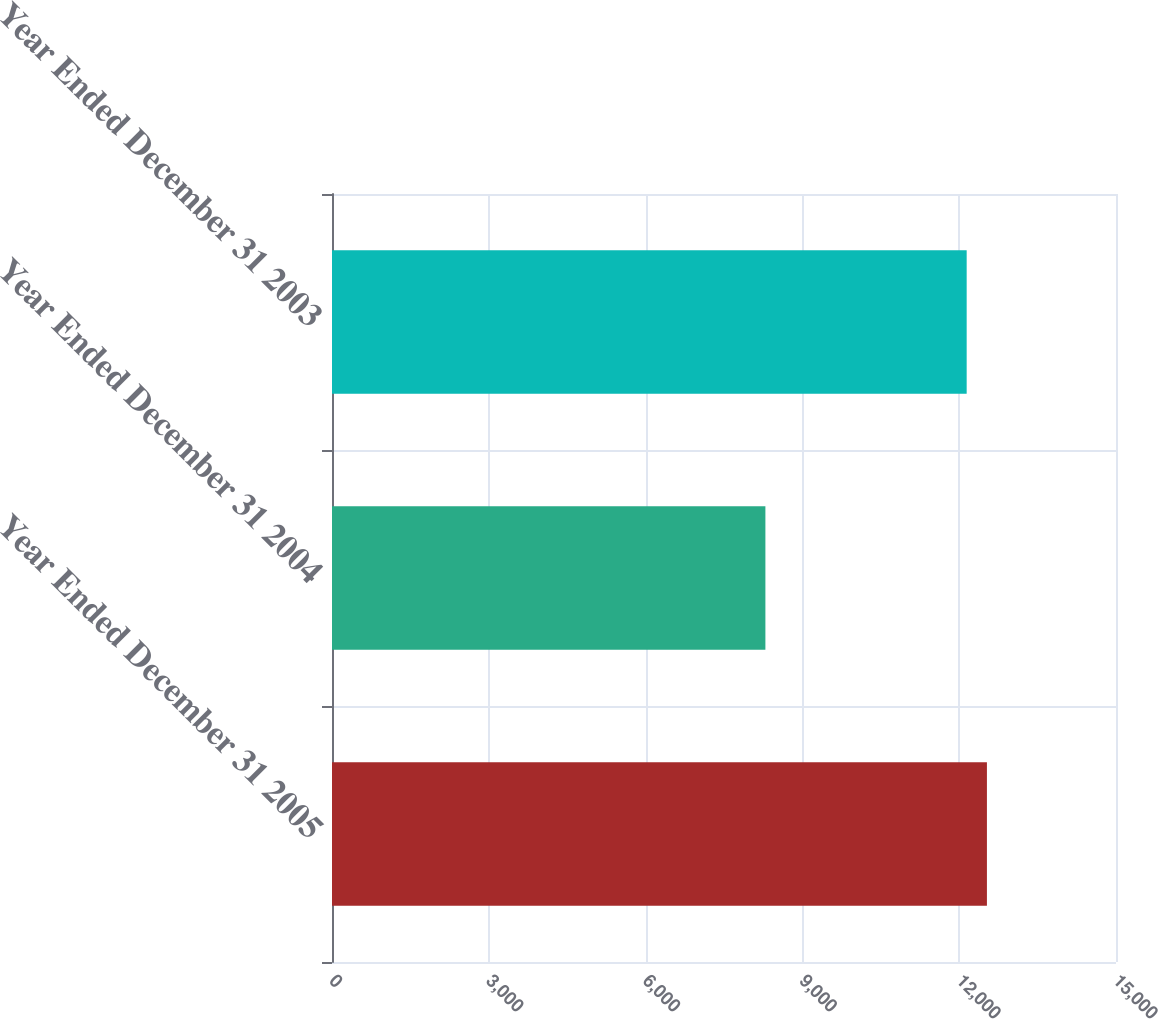Convert chart. <chart><loc_0><loc_0><loc_500><loc_500><bar_chart><fcel>Year Ended December 31 2005<fcel>Year Ended December 31 2004<fcel>Year Ended December 31 2003<nl><fcel>12530.4<fcel>8292<fcel>12143<nl></chart> 